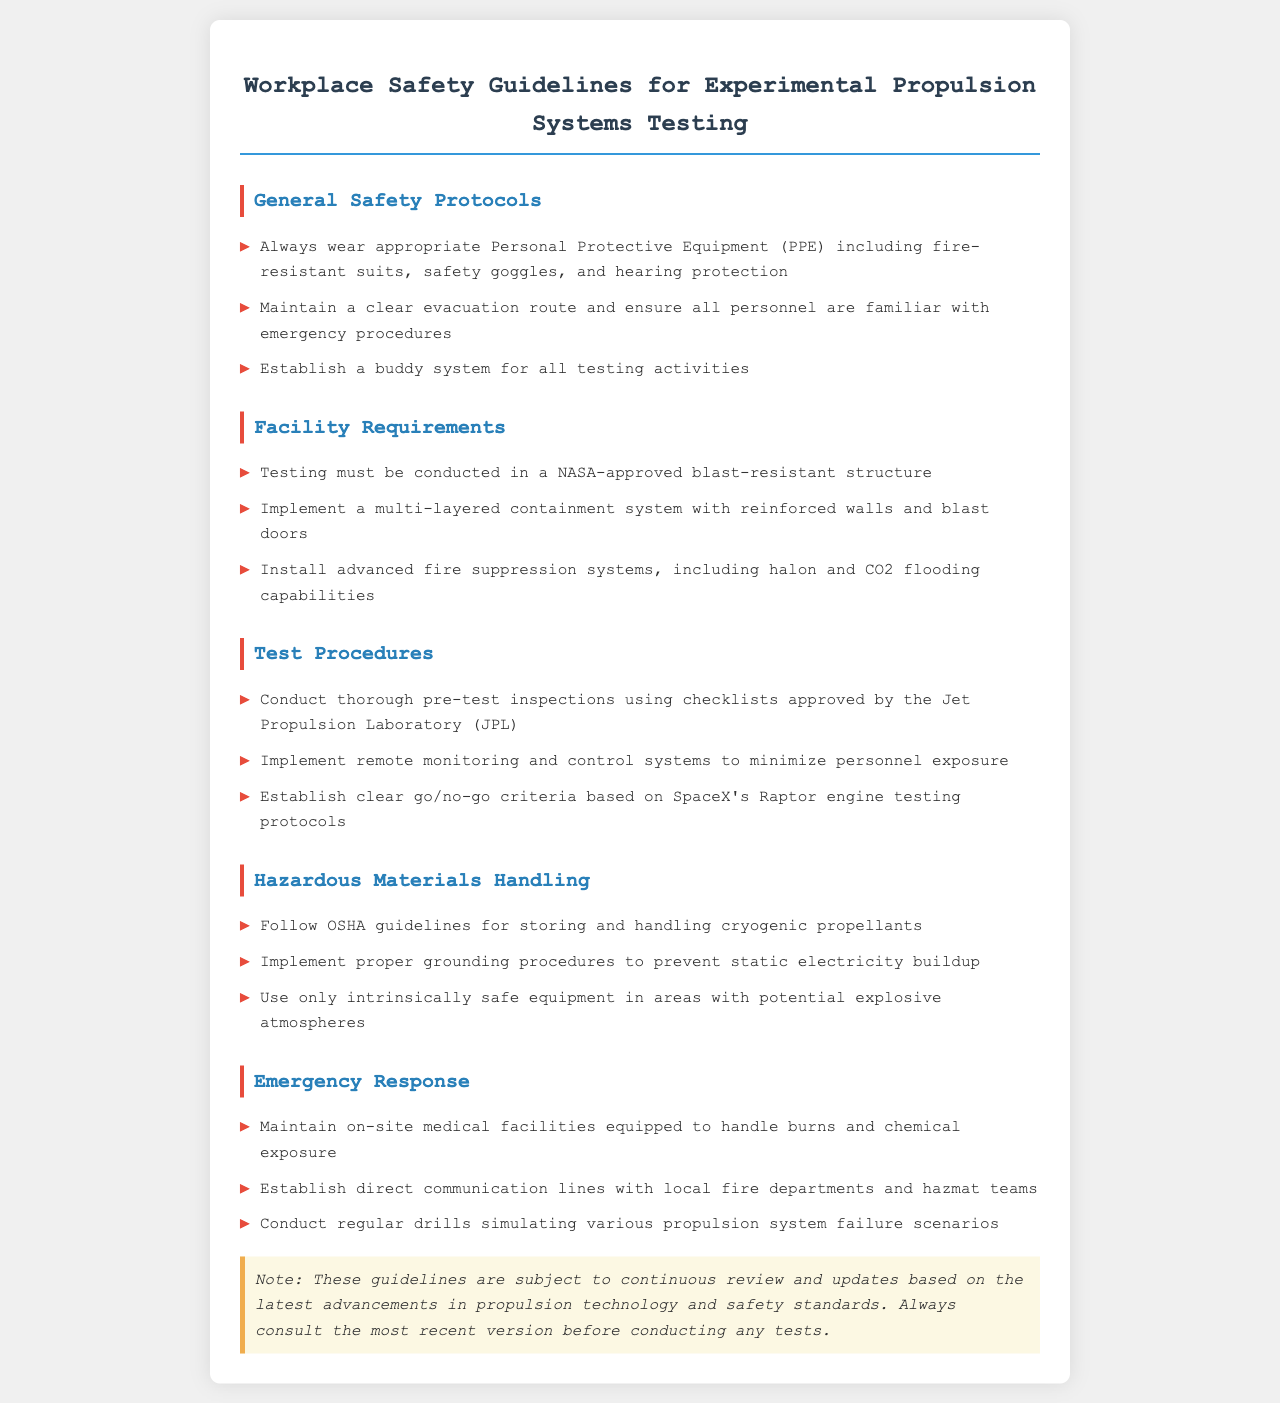What should be worn during testing? The document specifies that appropriate Personal Protective Equipment (PPE) such as fire-resistant suits, safety goggles, and hearing protection must be worn during testing.
Answer: PPE including fire-resistant suits, safety goggles, and hearing protection Where must testing be conducted? The guidelines state that testing should be conducted in a NASA-approved blast-resistant structure.
Answer: NASA-approved blast-resistant structure What type of system is required for fire suppression? The document requires advanced fire suppression systems, including halon and CO2 flooding capabilities.
Answer: Halon and CO2 flooding capabilities What organization’s checklist is used for pre-test inspections? The Jet Propulsion Laboratory (JPL) is mentioned as the organization whose checklists are approved for pre-test inspections.
Answer: Jet Propulsion Laboratory (JPL) What is a key feature of the buddy system? The guidelines outline that a buddy system must be established for all testing activities to ensure safety.
Answer: Established for all testing activities What must be maintained for emergency response? The document states that on-site medical facilities should be maintained to handle burns and chemical exposure.
Answer: On-site medical facilities Which department should be in direct communication for emergency response? The guidelines specify that direct communication lines should be established with local fire departments and hazmat teams.
Answer: Local fire departments and hazmat teams What is essential to handle cryogenic propellants? The document emphasizes following OSHA guidelines for storing and handling cryogenic propellants.
Answer: OSHA guidelines What should be conducted regularly according to the emergency response section? Regular drills simulating various propulsion system failure scenarios should be conducted as part of the emergency response protocols.
Answer: Regular drills simulating various propulsion system failure scenarios 